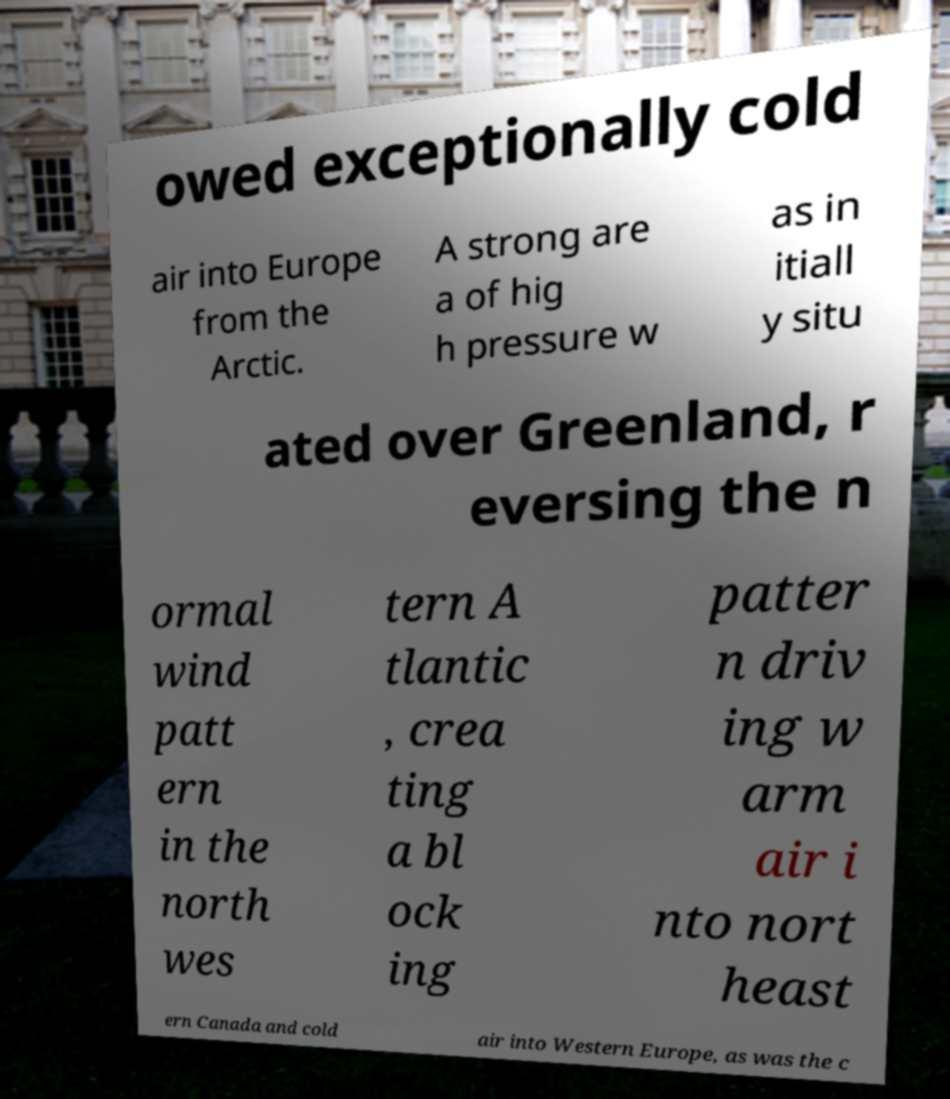I need the written content from this picture converted into text. Can you do that? owed exceptionally cold air into Europe from the Arctic. A strong are a of hig h pressure w as in itiall y situ ated over Greenland, r eversing the n ormal wind patt ern in the north wes tern A tlantic , crea ting a bl ock ing patter n driv ing w arm air i nto nort heast ern Canada and cold air into Western Europe, as was the c 